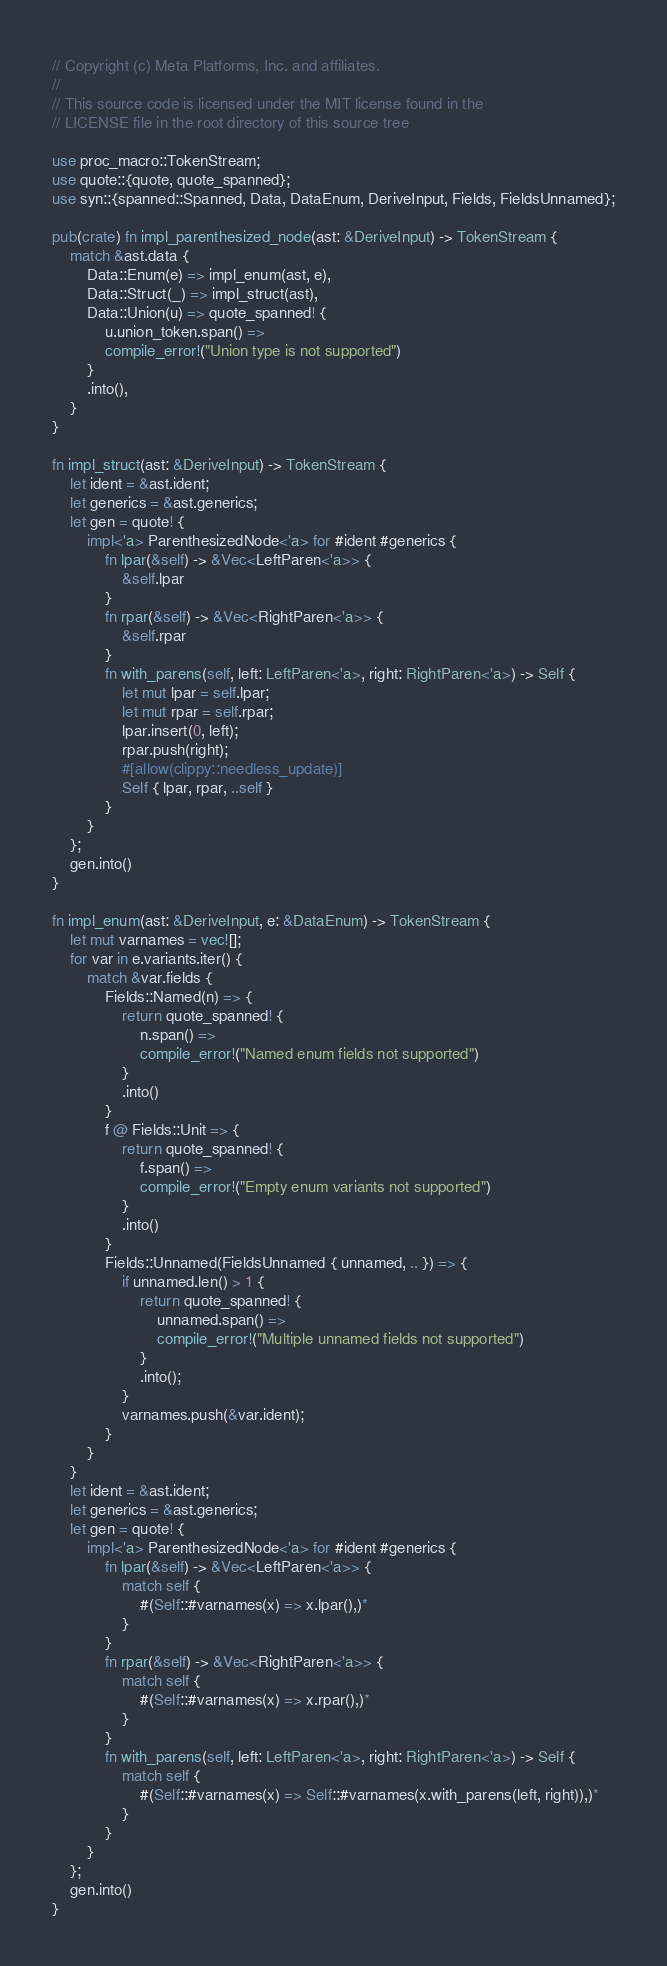<code> <loc_0><loc_0><loc_500><loc_500><_Rust_>// Copyright (c) Meta Platforms, Inc. and affiliates.
//
// This source code is licensed under the MIT license found in the
// LICENSE file in the root directory of this source tree

use proc_macro::TokenStream;
use quote::{quote, quote_spanned};
use syn::{spanned::Spanned, Data, DataEnum, DeriveInput, Fields, FieldsUnnamed};

pub(crate) fn impl_parenthesized_node(ast: &DeriveInput) -> TokenStream {
    match &ast.data {
        Data::Enum(e) => impl_enum(ast, e),
        Data::Struct(_) => impl_struct(ast),
        Data::Union(u) => quote_spanned! {
            u.union_token.span() =>
            compile_error!("Union type is not supported")
        }
        .into(),
    }
}

fn impl_struct(ast: &DeriveInput) -> TokenStream {
    let ident = &ast.ident;
    let generics = &ast.generics;
    let gen = quote! {
        impl<'a> ParenthesizedNode<'a> for #ident #generics {
            fn lpar(&self) -> &Vec<LeftParen<'a>> {
                &self.lpar
            }
            fn rpar(&self) -> &Vec<RightParen<'a>> {
                &self.rpar
            }
            fn with_parens(self, left: LeftParen<'a>, right: RightParen<'a>) -> Self {
                let mut lpar = self.lpar;
                let mut rpar = self.rpar;
                lpar.insert(0, left);
                rpar.push(right);
                #[allow(clippy::needless_update)]
                Self { lpar, rpar, ..self }
            }
        }
    };
    gen.into()
}

fn impl_enum(ast: &DeriveInput, e: &DataEnum) -> TokenStream {
    let mut varnames = vec![];
    for var in e.variants.iter() {
        match &var.fields {
            Fields::Named(n) => {
                return quote_spanned! {
                    n.span() =>
                    compile_error!("Named enum fields not supported")
                }
                .into()
            }
            f @ Fields::Unit => {
                return quote_spanned! {
                    f.span() =>
                    compile_error!("Empty enum variants not supported")
                }
                .into()
            }
            Fields::Unnamed(FieldsUnnamed { unnamed, .. }) => {
                if unnamed.len() > 1 {
                    return quote_spanned! {
                        unnamed.span() =>
                        compile_error!("Multiple unnamed fields not supported")
                    }
                    .into();
                }
                varnames.push(&var.ident);
            }
        }
    }
    let ident = &ast.ident;
    let generics = &ast.generics;
    let gen = quote! {
        impl<'a> ParenthesizedNode<'a> for #ident #generics {
            fn lpar(&self) -> &Vec<LeftParen<'a>> {
                match self {
                    #(Self::#varnames(x) => x.lpar(),)*
                }
            }
            fn rpar(&self) -> &Vec<RightParen<'a>> {
                match self {
                    #(Self::#varnames(x) => x.rpar(),)*
                }
            }
            fn with_parens(self, left: LeftParen<'a>, right: RightParen<'a>) -> Self {
                match self {
                    #(Self::#varnames(x) => Self::#varnames(x.with_parens(left, right)),)*
                }
            }
        }
    };
    gen.into()
}
</code> 